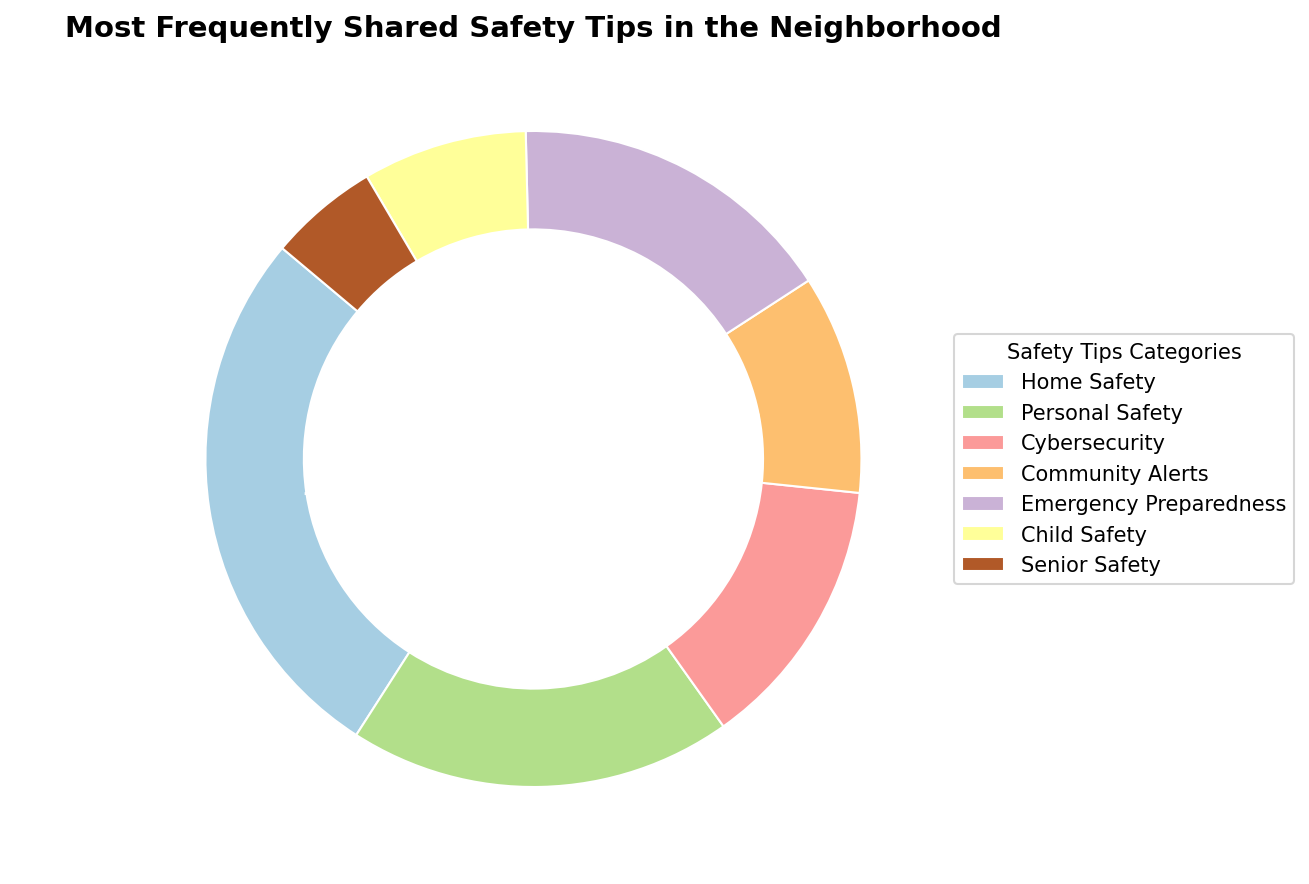What percentage of tips are related to Home Safety? The segment labeled "Home Safety" on the pie chart shows a percentage next to it. According to the data, Home Safety accounts for 50 out of 185 total tips shared. Therefore, the Home Safety segment is 50 divided by 185, which equals approximately 27%.
Answer: 27% Which category has the least number of tips shared? By examining the smallest segment on the pie chart, which is labeled "Senior Safety," it's evident that this category has the least number of tips shared, with only 10 counts.
Answer: Senior Safety How many more tips are shared about Home Safety compared to Cybersecurity? The Home Safety segment represents 50 tips, while the Cybersecurity segment represents 25 tips. To find the difference, subtract 25 from 50.
Answer: 25 What is the combined percentage of tips shared for Community Alerts and Emergency Preparedness? Community Alerts account for 20 tips, and Emergency Preparedness accounts for 30 tips. Together that makes 50 tips out of 185 total tips. The combined percentage is (50 / 185) * 100, which equals approximately 27%.
Answer: 27% Which category has the second highest number of tips shared? Looking at the second largest segment on the pie chart, the "Personal Safety" segment shows 35 tips, which is the second highest count after "Home Safety."
Answer: Personal Safety Is the percentage of Child Safety tips shared higher or lower than that of Cybersecurity? By comparing the segments on the pie chart, Child Safety represents 15 tips, and Cybersecurity represents 25 tips. Since 15 is less than 25, the Child Safety segment's percentage is lower than that of Cybersecurity.
Answer: Lower What is the total count of tips shared in all categories? Summing up all the counts from the segments—Home Safety (50), Personal Safety (35), Cybersecurity (25), Community Alerts (20), Emergency Preparedness (30), Child Safety (15), Senior Safety (10)—you get 185 in total.
Answer: 185 What is the average number of tips shared across all categories? The total count of tips is 185, and there are 7 categories. The average number of tips is 185 divided by 7, which is approximately 26.4.
Answer: 26.4 If Emergency Preparedness tips were doubled, would it have the highest count among all categories? Emergency Preparedness currently has 30 tips. If doubled, it would have 60 tips. Comparing it to Home Safety, which has 50 tips, 60 is greater than 50, so yes, it would then have the highest count.
Answer: Yes 